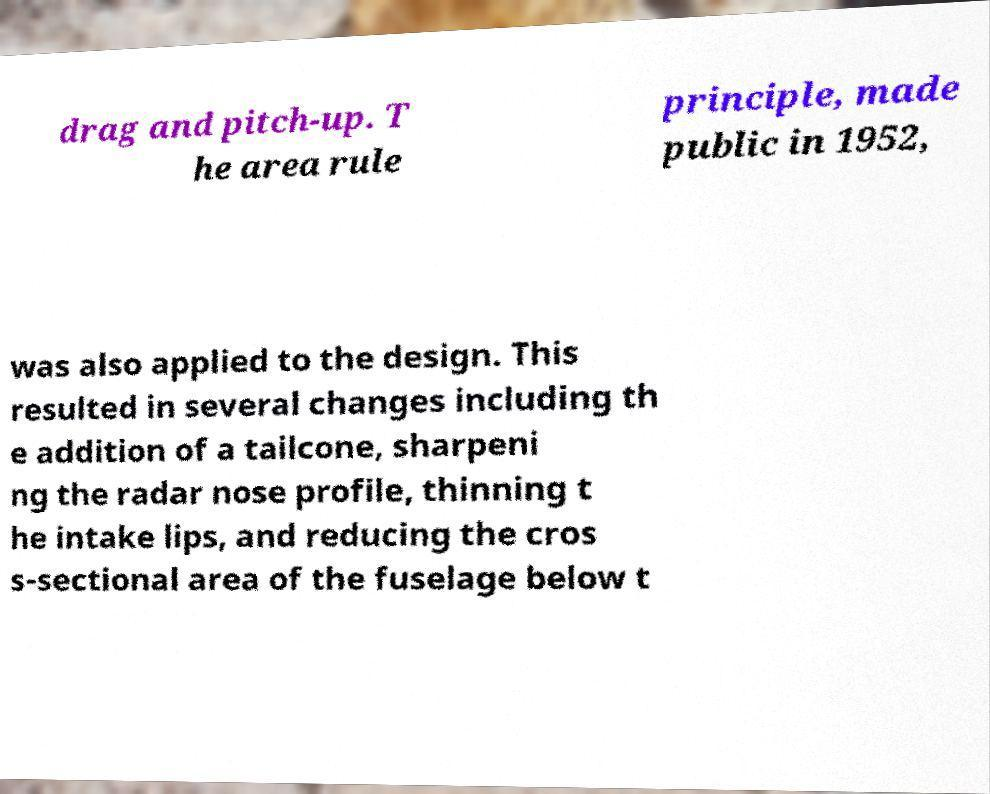Could you assist in decoding the text presented in this image and type it out clearly? drag and pitch-up. T he area rule principle, made public in 1952, was also applied to the design. This resulted in several changes including th e addition of a tailcone, sharpeni ng the radar nose profile, thinning t he intake lips, and reducing the cros s-sectional area of the fuselage below t 